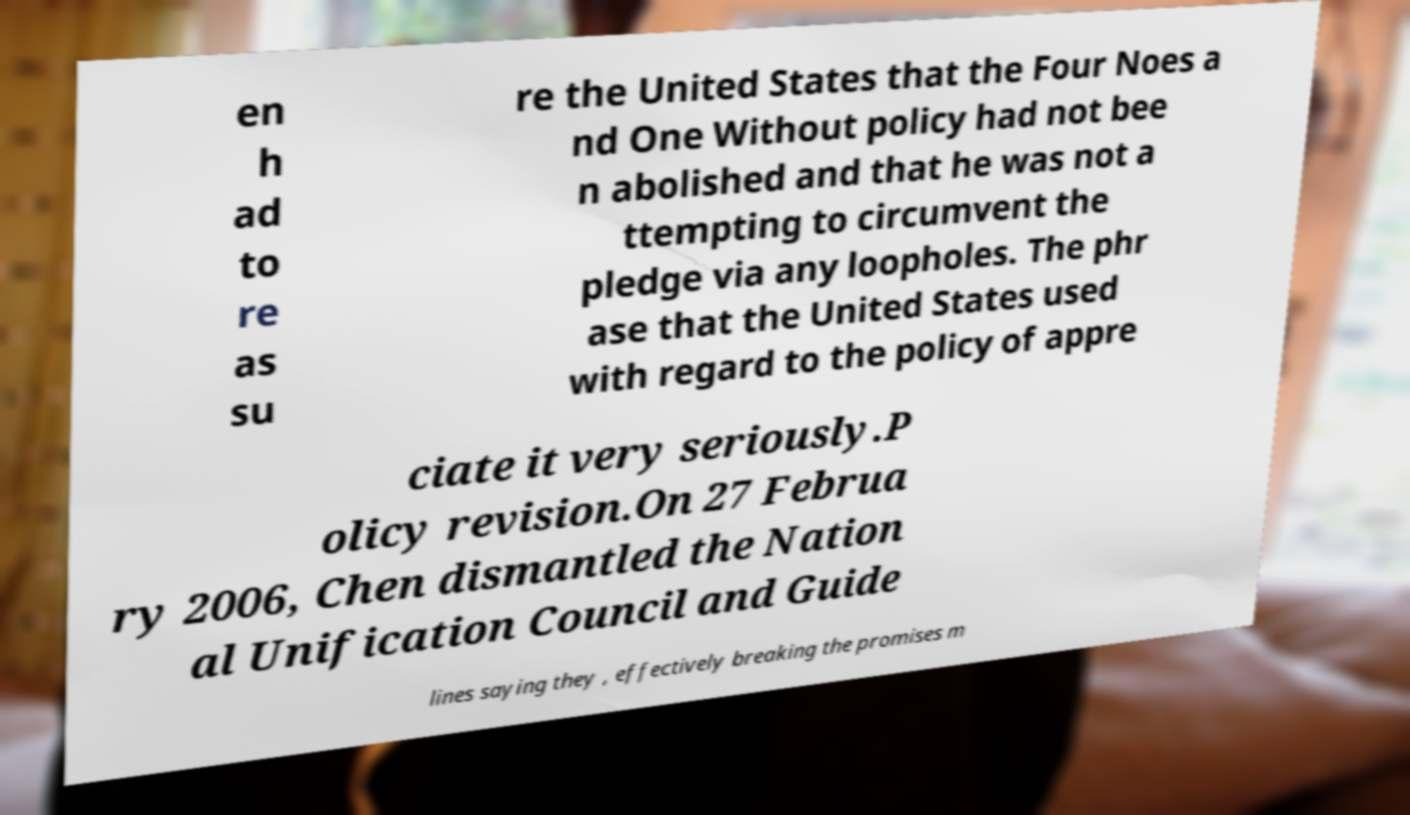Please identify and transcribe the text found in this image. en h ad to re as su re the United States that the Four Noes a nd One Without policy had not bee n abolished and that he was not a ttempting to circumvent the pledge via any loopholes. The phr ase that the United States used with regard to the policy of appre ciate it very seriously.P olicy revision.On 27 Februa ry 2006, Chen dismantled the Nation al Unification Council and Guide lines saying they , effectively breaking the promises m 